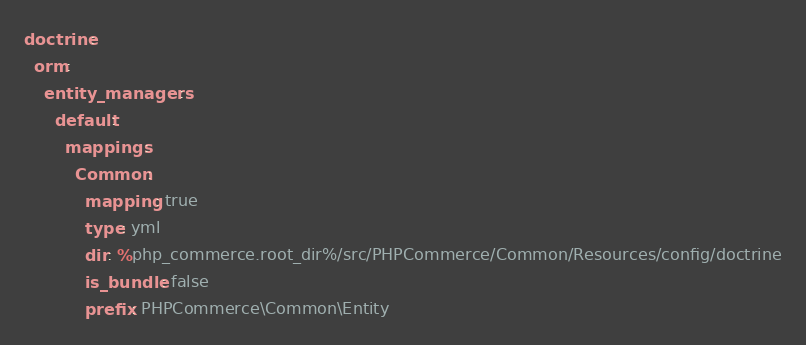Convert code to text. <code><loc_0><loc_0><loc_500><loc_500><_YAML_>doctrine:
  orm:
    entity_managers:
      default:
        mappings:
          Common:
            mapping: true
            type: yml
            dir: %php_commerce.root_dir%/src/PHPCommerce/Common/Resources/config/doctrine
            is_bundle: false
            prefix: PHPCommerce\Common\Entity
</code> 